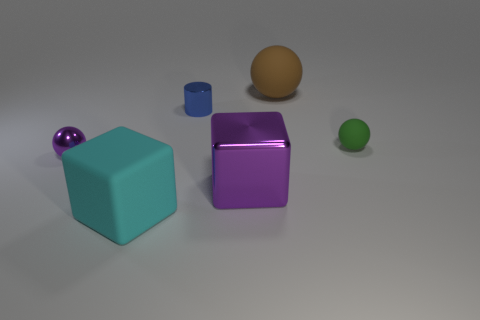Add 3 tiny things. How many objects exist? 9 Subtract all cubes. How many objects are left? 4 Add 4 tiny purple metallic blocks. How many tiny purple metallic blocks exist? 4 Subtract 0 cyan spheres. How many objects are left? 6 Subtract all cyan metal cubes. Subtract all balls. How many objects are left? 3 Add 2 green things. How many green things are left? 3 